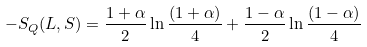Convert formula to latex. <formula><loc_0><loc_0><loc_500><loc_500>- S _ { Q } ( L , S ) = \frac { 1 + \alpha } { 2 } \ln { \frac { ( 1 + \alpha ) } { 4 } } + \frac { 1 - \alpha } { 2 } \ln { \frac { ( 1 - \alpha ) } { 4 } }</formula> 